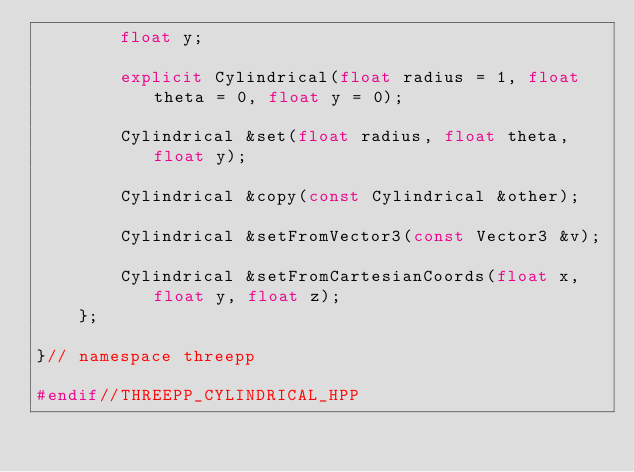Convert code to text. <code><loc_0><loc_0><loc_500><loc_500><_C++_>        float y;

        explicit Cylindrical(float radius = 1, float theta = 0, float y = 0);

        Cylindrical &set(float radius, float theta, float y);

        Cylindrical &copy(const Cylindrical &other);

        Cylindrical &setFromVector3(const Vector3 &v);

        Cylindrical &setFromCartesianCoords(float x, float y, float z);
    };

}// namespace threepp

#endif//THREEPP_CYLINDRICAL_HPP
</code> 